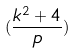Convert formula to latex. <formula><loc_0><loc_0><loc_500><loc_500>( \frac { k ^ { 2 } + 4 } { p } )</formula> 